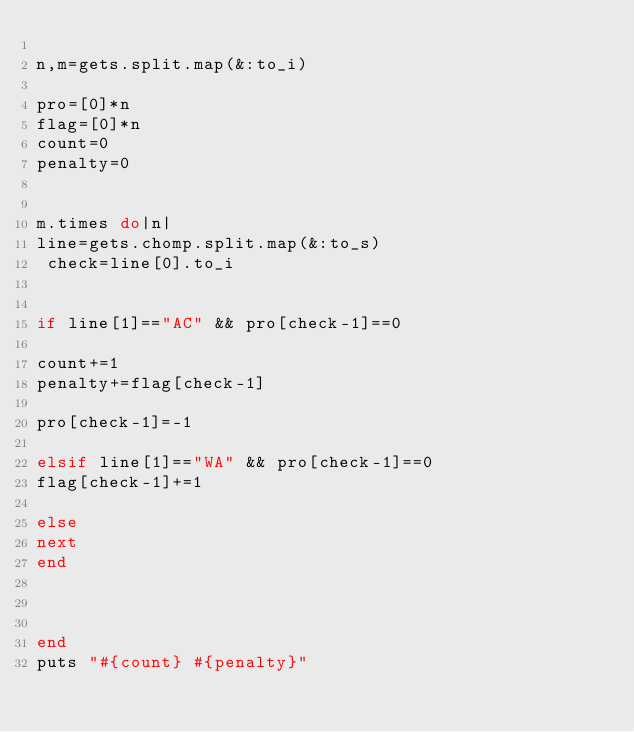<code> <loc_0><loc_0><loc_500><loc_500><_Ruby_>
n,m=gets.split.map(&:to_i)
 
pro=[0]*n
flag=[0]*n
count=0
penalty=0


m.times do|n|
line=gets.chomp.split.map(&:to_s)
 check=line[0].to_i
 
    
if line[1]=="AC" && pro[check-1]==0
   
count+=1
penalty+=flag[check-1]

pro[check-1]=-1
 
elsif line[1]=="WA" && pro[check-1]==0
flag[check-1]+=1

else
next
end
    
    
 
end
puts "#{count} #{penalty}"</code> 